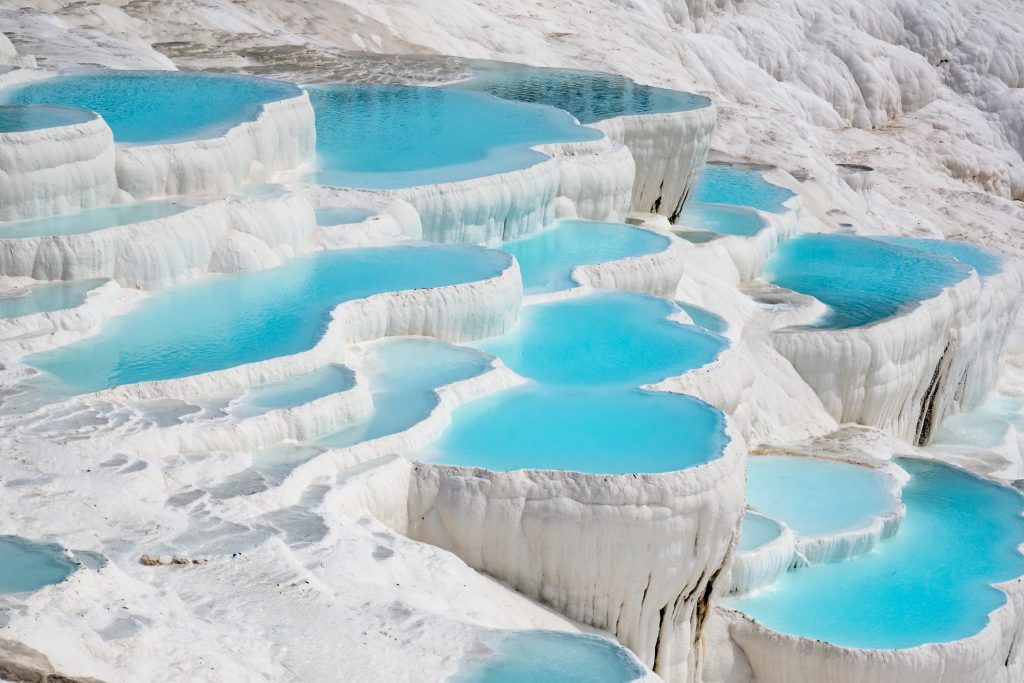Imagine you are visiting Pamukkale. What activities would you recommend for a memorable experience? Visiting Pamukkale offers a unique and memorable experience. To make the most of your trip, you could start with a leisurely stroll along the travertine terraces, feeling the mineral-rich waters flow around your feet. Next, head to the ancient city of Hierapolis to explore its fascinating ruins, including the grand theater, the Temple of Apollo, and the necropolis. Don’t miss the chance to take a dip in the Sacred Pool (Cleopatra’s Pool), where you can swim among ancient columns in thermal waters. Finally, as the day winds down, find a scenic spot to watch the sunset over the terraces—the shifting colors create a mesmerizing spectacle. What else can one explore in the surrounding areas of Pamukkale? Beyond Pamukkale, you can explore the nearby modern town of Denizli, known for its textile industry and vibrant local market. For a more adventurous experience, consider visiting Kaklik Cave, which features stunning stalactites and clear subterranean waters. Additionally, the Laodicea ruins, an ancient city of major historical significance, are just a short drive away, offering insights into the region's rich past. To immerse yourself in local culture, try visiting some of the traditional villages, where you can experience authentic Turkish hospitality and cuisine. 